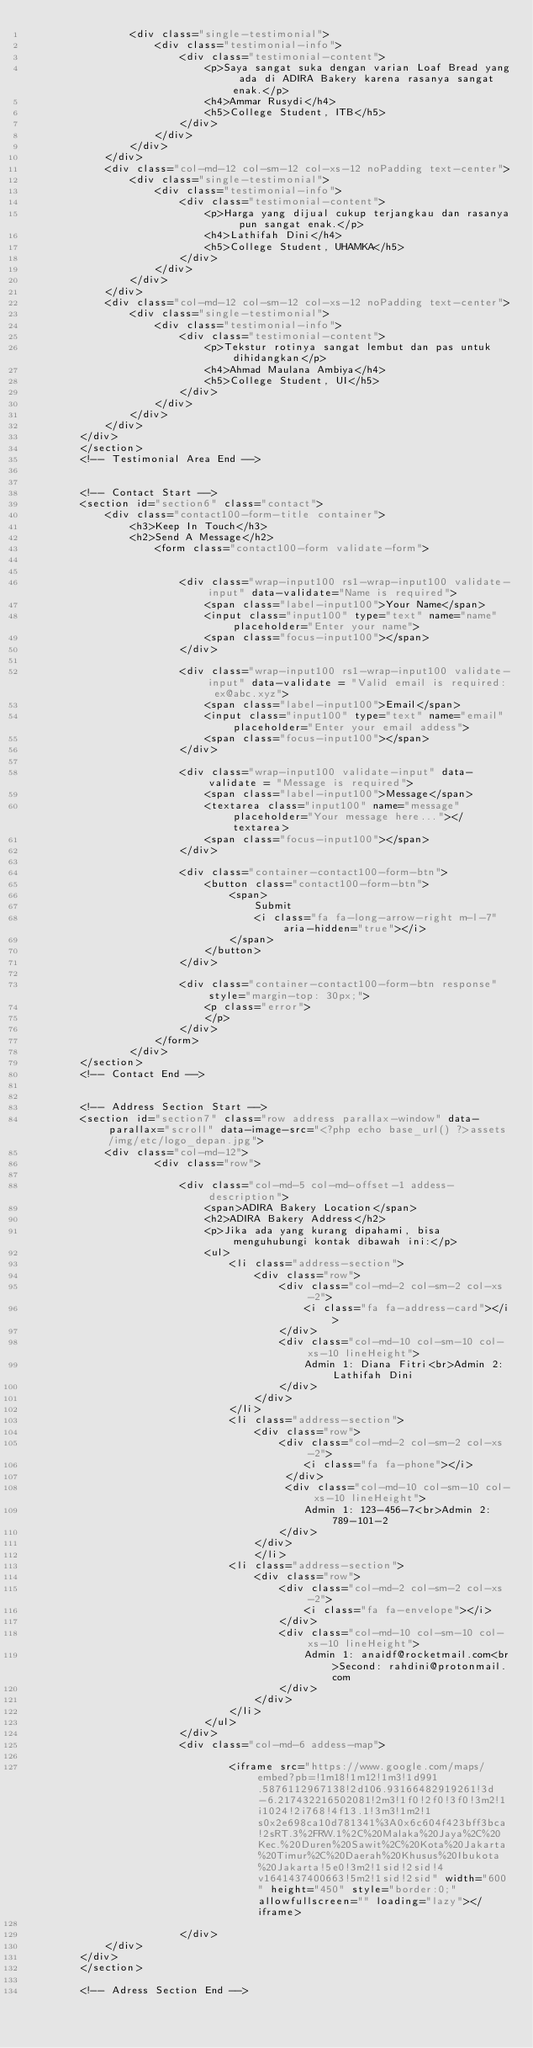<code> <loc_0><loc_0><loc_500><loc_500><_PHP_>                <div class="single-testimonial">
                    <div class="testimonial-info">
                        <div class="testimonial-content">
                            <p>Saya sangat suka dengan varian Loaf Bread yang ada di ADIRA Bakery karena rasanya sangat enak.</p>
                            <h4>Ammar Rusydi</h4>
                            <h5>College Student, ITB</h5>
                        </div>
                    </div>
                </div>
            </div> 
            <div class="col-md-12 col-sm-12 col-xs-12 noPadding text-center">
                <div class="single-testimonial">
                    <div class="testimonial-info">
                        <div class="testimonial-content">
                            <p>Harga yang dijual cukup terjangkau dan rasanya pun sangat enak.</p>
                            <h4>Lathifah Dini</h4>
                            <h5>College Student, UHAMKA</h5>
                        </div>
                    </div>
                </div>
            </div> 
            <div class="col-md-12 col-sm-12 col-xs-12 noPadding text-center">
                <div class="single-testimonial">
                    <div class="testimonial-info">
                        <div class="testimonial-content">
                            <p>Tekstur rotinya sangat lembut dan pas untuk dihidangkan</p>
                            <h4>Ahmad Maulana Ambiya</h4>
                            <h5>College Student, UI</h5>
                        </div>
                    </div>
                </div>
            </div> 
        </div>
        </section>
        <!-- Testimonial Area End -->


        <!-- Contact Start -->
        <section id="section6" class="contact">
            <div class="contact100-form-title container">
                <h3>Keep In Touch</h3>
                <h2>Send A Message</h2>
                    <form class="contact100-form validate-form">
                       

                        <div class="wrap-input100 rs1-wrap-input100 validate-input" data-validate="Name is required">
                            <span class="label-input100">Your Name</span>
                            <input class="input100" type="text" name="name" placeholder="Enter your name">
                            <span class="focus-input100"></span>
                        </div>

                        <div class="wrap-input100 rs1-wrap-input100 validate-input" data-validate = "Valid email is required: ex@abc.xyz">
                            <span class="label-input100">Email</span>
                            <input class="input100" type="text" name="email" placeholder="Enter your email addess">
                            <span class="focus-input100"></span>
                        </div>

                        <div class="wrap-input100 validate-input" data-validate = "Message is required">
                            <span class="label-input100">Message</span>
                            <textarea class="input100" name="message" placeholder="Your message here..."></textarea>
                            <span class="focus-input100"></span>
                        </div>

                        <div class="container-contact100-form-btn">
                            <button class="contact100-form-btn">
                                <span>
                                    Submit
                                    <i class="fa fa-long-arrow-right m-l-7" aria-hidden="true"></i>
                                </span>
                            </button>
                        </div>

                        <div class="container-contact100-form-btn response" style="margin-top: 30px;">
                            <p class="error">
                            </p>
                        </div>
                    </form>
                </div>
        </section>
        <!-- Contact End -->
        

        <!-- Address Section Start -->
        <section id="section7" class="row address parallax-window" data-parallax="scroll" data-image-src="<?php echo base_url() ?>assets/img/etc/logo_depan.jpg">
            <div class="col-md-12">
                    <div class="row">

                        <div class="col-md-5 col-md-offset-1 addess-description">
                            <span>ADIRA Bakery Location</span>
                            <h2>ADIRA Bakery Address</h2>
                            <p>Jika ada yang kurang dipahami, bisa menguhubungi kontak dibawah ini:</p>
                            <ul>
                                <li class="address-section">
                                    <div class="row">
                                        <div class="col-md-2 col-sm-2 col-xs-2">
                                            <i class="fa fa-address-card"></i>
                                        </div>
                                        <div class="col-md-10 col-sm-10 col-xs-10 lineHeight">
                                            Admin 1: Diana Fitri<br>Admin 2: Lathifah Dini
                                        </div>
                                    </div>
                                </li>
                                <li class="address-section">
                                    <div class="row">
                                        <div class="col-md-2 col-sm-2 col-xs-2">
                                            <i class="fa fa-phone"></i>                                       
                                         </div>
                                         <div class="col-md-10 col-sm-10 col-xs-10 lineHeight">
                                            Admin 1: 123-456-7<br>Admin 2: 789-101-2
                                        </div>
                                    </div>
                                    </li>
                                <li class="address-section">
                                    <div class="row">
                                        <div class="col-md-2 col-sm-2 col-xs-2">
                                            <i class="fa fa-envelope"></i>                                       
                                        </div>
                                        <div class="col-md-10 col-sm-10 col-xs-10 lineHeight">
                                            Admin 1: anaidf@rocketmail.com<br>Second: rahdini@protonmail.com
                                        </div>
                                    </div>
                                </li>
                            </ul>
                        </div>
                        <div class="col-md-6 addess-map">
                            
                                <iframe src="https://www.google.com/maps/embed?pb=!1m18!1m12!1m3!1d991.5876112967138!2d106.93166482919261!3d-6.217432216502081!2m3!1f0!2f0!3f0!3m2!1i1024!2i768!4f13.1!3m3!1m2!1s0x2e698ca10d781341%3A0x6c604f423bff3bca!2sRT.3%2FRW.1%2C%20Malaka%20Jaya%2C%20Kec.%20Duren%20Sawit%2C%20Kota%20Jakarta%20Timur%2C%20Daerah%20Khusus%20Ibukota%20Jakarta!5e0!3m2!1sid!2sid!4v1641437400663!5m2!1sid!2sid" width="600" height="450" style="border:0;" allowfullscreen="" loading="lazy"></iframe>

                        </div>
            </div>
        </div>
        </section>

        <!-- Adress Section End --></code> 